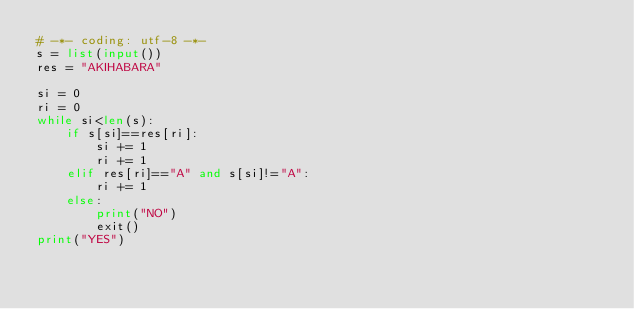<code> <loc_0><loc_0><loc_500><loc_500><_Python_># -*- coding: utf-8 -*-
s = list(input())
res = "AKIHABARA"

si = 0
ri = 0
while si<len(s):
    if s[si]==res[ri]:
        si += 1
        ri += 1
    elif res[ri]=="A" and s[si]!="A":
        ri += 1
    else:
        print("NO")
        exit()
print("YES")
</code> 